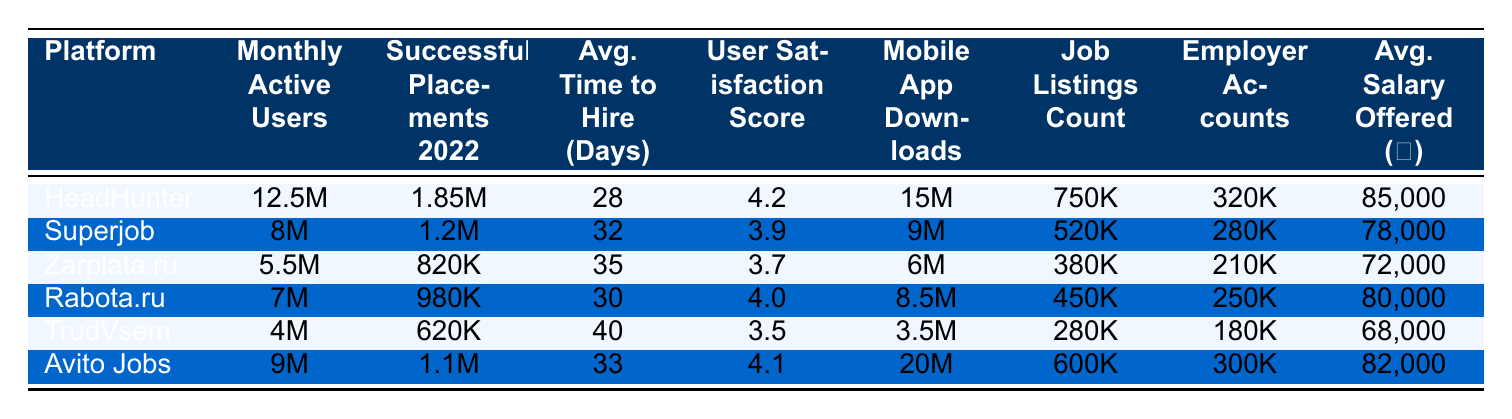What is the platform with the highest user satisfaction score? Looking at the user satisfaction scores in the table, HeadHunter has a score of 4.2, which is the highest among all listed platforms.
Answer: HeadHunter How many monthly active users does Superjob have? The table indicates that Superjob has 8 million monthly active users.
Answer: 8 million What is the average time to hire for Zarplata.ru? According to the table, the average time to hire for Zarplata.ru is 35 days.
Answer: 35 days Which platform has the most successful placements in 2022? By comparing the successful placements figures, HeadHunter has 1.85 million successful placements, the highest number.
Answer: HeadHunter What is the average salary offered by Rabota.ru in rubles? The table shows that Rabota.ru offers an average salary of 80,000 rubles.
Answer: 80,000 rubles How many job listings does TrudVsem have compared to Superjob? TrudVsem has 280,000 job listings while Superjob has 520,000. The difference is 520,000 - 280,000 = 240,000 listings, so Superjob has 240,000 more listings.
Answer: Superjob has 240,000 more listings What is the total number of mobile app downloads for all platforms combined? To find the total, we add up the mobile app downloads: 15M + 9M + 6M + 8.5M + 3.5M + 20M = 62M downloads.
Answer: 62 million downloads Is the average time to hire longer for TrudVsem than for Avito Jobs? TrudVsem takes 40 days on average while Avito Jobs takes 33 days, so yes, TrudVsem's average time to hire is longer.
Answer: Yes Based on the data, does having more monthly active users correlate with a higher number of successful placements? We analyze the table: HeadHunter has the highest users and placements, Superjob has lower user numbers but high placements, while TrudVsem has the lowest users and placements. This suggests a weak correlation; however, deeper analysis may be needed.
Answer: No clear correlation How does the average salary offered by job search platforms compare to the user satisfaction scores? By comparing the averages: HeadHunter has a high score (4.2) and high salary (85,000), while TrudVsem has low scores (3.5) and low salary (68,000). A general trend seems that higher satisfaction relates to higher offered salaries, but it is not consistent across all platforms.
Answer: Generally higher satisfaction relates to higher salaries If a user were to choose a platform solely based on the number of successful placements, which should they choose? HeadHunter has the most successful placements (1.85 million), making it the platform to choose based on that metric alone.
Answer: HeadHunter 